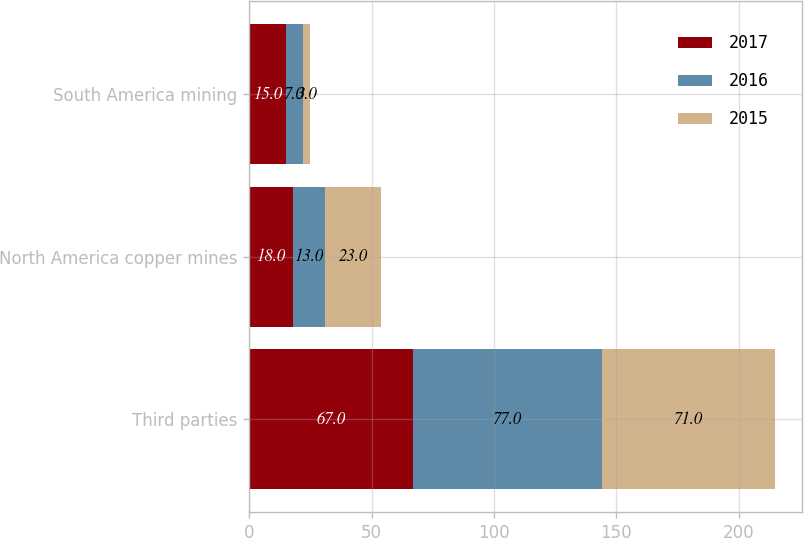<chart> <loc_0><loc_0><loc_500><loc_500><stacked_bar_chart><ecel><fcel>Third parties<fcel>North America copper mines<fcel>South America mining<nl><fcel>2017<fcel>67<fcel>18<fcel>15<nl><fcel>2016<fcel>77<fcel>13<fcel>7<nl><fcel>2015<fcel>71<fcel>23<fcel>3<nl></chart> 